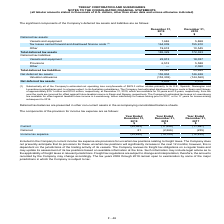According to Teekay Corporation's financial document, What is included in current income tax expense? provisions for uncertain tax positions relating to freight taxes.. The document states: "ed in the Company's current income tax expense are provisions for uncertain tax positions relating to freight taxes. The Company does not presently an..." Also, What will determine the tax positions in the next 12 months? dependent on the jurisdictions of the trading activity of its vessels.. The document states: "y increase in the next 12 months; however, this is dependent on the jurisdictions of the trading activity of its vessels. The Company reviews its frei..." Also, Which tax years are open to examination by jurisdictions? The tax years 2008 through 2019 remain open to examination. The document states: "s recorded by the Company may change accordingly. The tax years 2008 through 2019 remain open to examination by some of the major jurisdictions in whi..." Also, can you calculate: What is the change in Current income tax expense from December 31, 2019 to December 31, 2018? Based on the calculation: 25,563-17,458, the result is 8105 (in thousands). This is based on the information: "Current (25,563) (17,458) (11,997) Current (25,563) (17,458) (11,997)..." The key data points involved are: 17,458, 25,563. Additionally, Which year has higher current income tax expense? According to the financial document, 2019. The relevant text states: "2019..." Also, can you calculate: What is the change in Income tax expense from December 31, 2019 to December 31, 2018? Based on the calculation: 25,482-19,724, the result is 5758 (in thousands). This is based on the information: "Income tax expense (25,482) (19,724) (12,232) Income tax expense (25,482) (19,724) (12,232)..." The key data points involved are: 19,724, 25,482. 